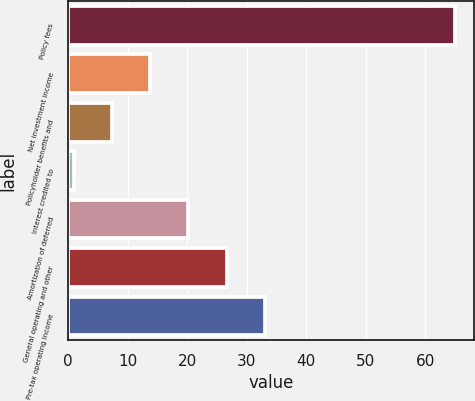Convert chart to OTSL. <chart><loc_0><loc_0><loc_500><loc_500><bar_chart><fcel>Policy fees<fcel>Net investment income<fcel>Policyholder benefits and<fcel>Interest credited to<fcel>Amortization of deferred<fcel>General operating and other<fcel>Pre-tax operating income<nl><fcel>65<fcel>13.8<fcel>7.4<fcel>1<fcel>20.2<fcel>26.6<fcel>33<nl></chart> 